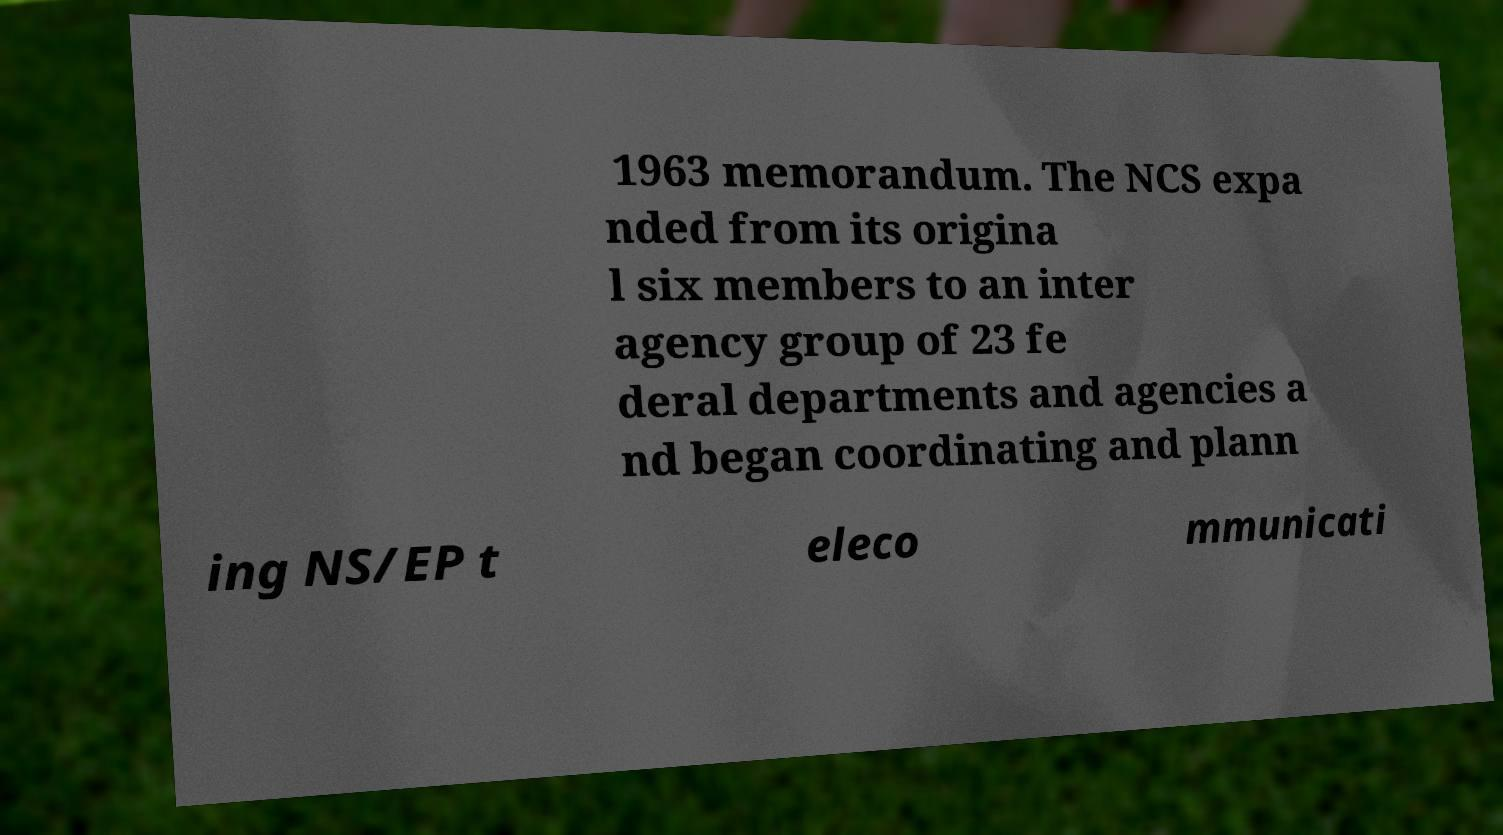Please read and relay the text visible in this image. What does it say? 1963 memorandum. The NCS expa nded from its origina l six members to an inter agency group of 23 fe deral departments and agencies a nd began coordinating and plann ing NS/EP t eleco mmunicati 